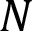Convert formula to latex. <formula><loc_0><loc_0><loc_500><loc_500>N</formula> 